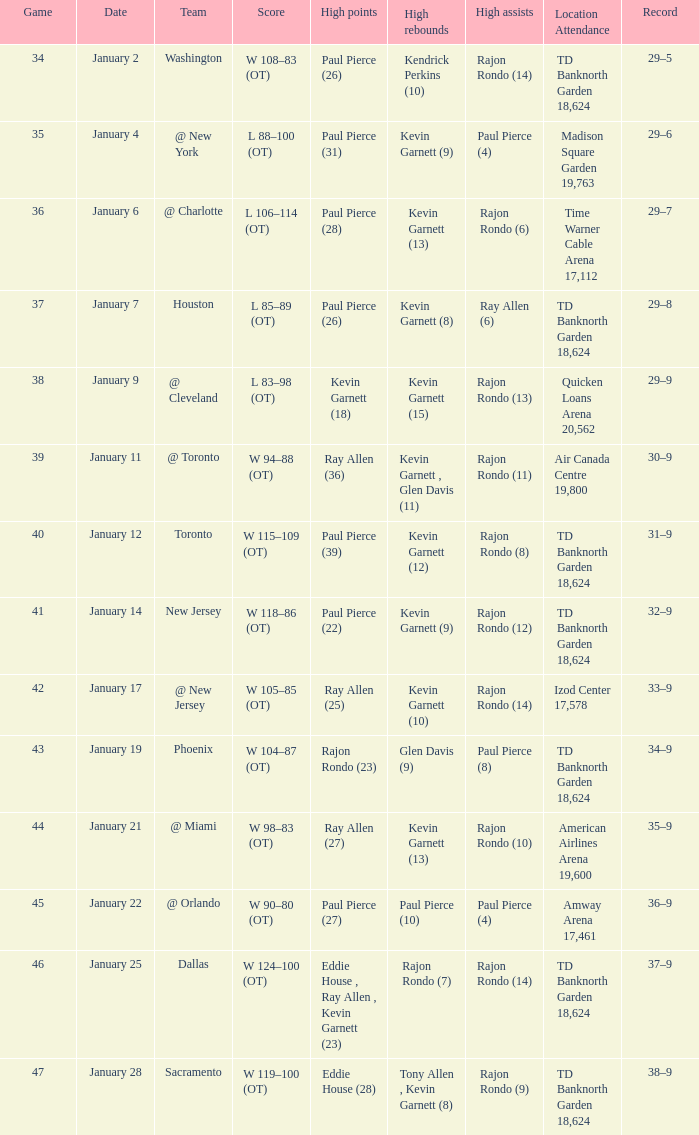Who had the high rebound total on january 6? Kevin Garnett (13). 